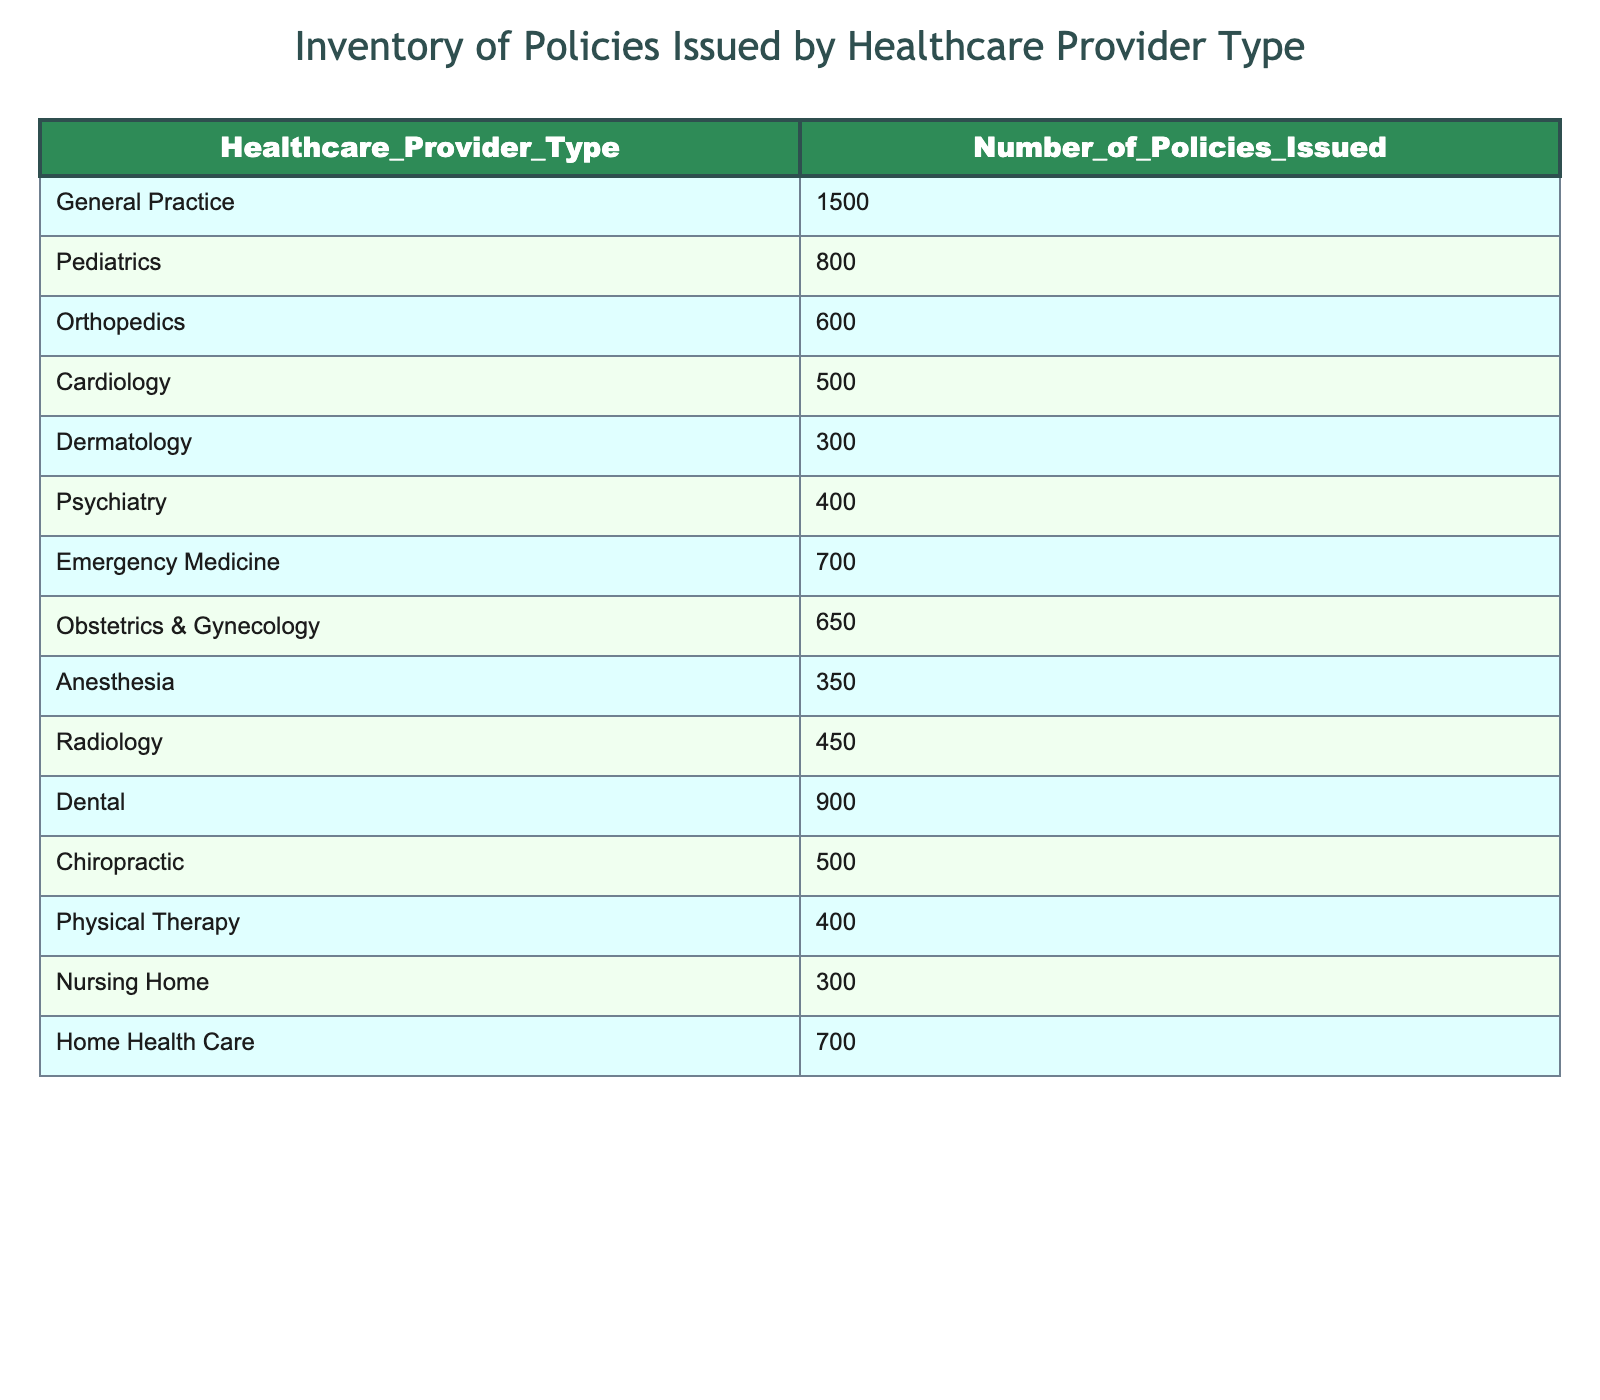What is the total number of policies issued for Emergency Medicine and Cardiology combined? To find the total number of policies for Emergency Medicine and Cardiology, we look at their respective values: Emergency Medicine has 700 policies, and Cardiology has 500 policies. We then add these two amounts together: 700 + 500 = 1200.
Answer: 1200 Which healthcare provider type has the lowest number of policies issued? By examining the table, we can identify the healthcare provider types with their corresponding number of policies. The lowest number is found under Dermatology, which has 300 policies issued.
Answer: Dermatology Is it true that Pediatrics has more policies issued than Anesthesia? We compare the values: Pediatrics has 800 policies while Anesthesia has 350 policies. Since 800 is greater than 350, the statement is true.
Answer: Yes What is the average number of policies issued for the types of providers that issue more than 600 policies? We first identify the provider types issuing more than 600 policies: General Practice (1500), Pediatrics (800), Emergency Medicine (700), Obstetrics & Gynecology (650). We sum these amounts: 1500 + 800 + 700 + 650 = 3650. Next, we divide by the number of provider types, which is 4: 3650 / 4 = 912.5.
Answer: 912.5 How many more policies are issued for General Practice than for the total of Pediatrics and Psychiatry combined? First, we find the number of policies for Pediatrics (800) and Psychiatry (400). Adding these gives us: 800 + 400 = 1200. General Practice has 1500 policies. We then subtract the total of Pediatrics and Psychiatry from General Practice: 1500 - 1200 = 300.
Answer: 300 Which provider type has issued no more than 400 policies? Reviewing the list, we check which types have values less than or equal to 400. The provider types that fit this criteria are Dermatology (300), Nursing Home (300), and Physical Therapy (400).
Answer: Dermatology, Nursing Home, Physical Therapy What percentage of the total policies issued belong to Dental? First, we find the total number of policies issued by adding all types together: 1500 + 800 + 600 + 500 + 300 + 400 + 700 + 650 + 350 + 450 + 900 + 500 + 400 + 300 + 700 = 10000. Then, we find the number of policies for Dental which is 900. The percentage is calculated as (900 / 10000) * 100 = 9%.
Answer: 9% What is the difference in the number of policies between the highest and lowest provider types? The highest number of policies is from General Practice (1500) and the lowest is from Dermatology (300). The difference is calculated by subtracting the lowest from the highest: 1500 - 300 = 1200.
Answer: 1200 